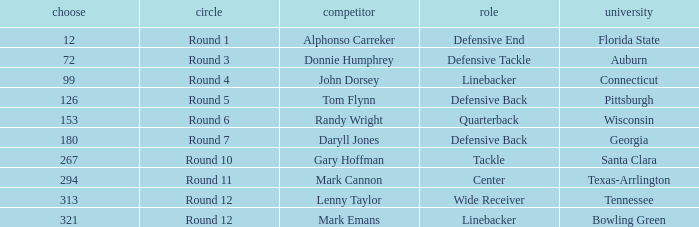What is the Position of Pick #321? Linebacker. 